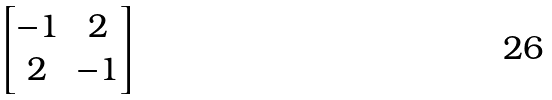<formula> <loc_0><loc_0><loc_500><loc_500>\begin{bmatrix} - 1 & 2 \\ 2 & - 1 \end{bmatrix}</formula> 